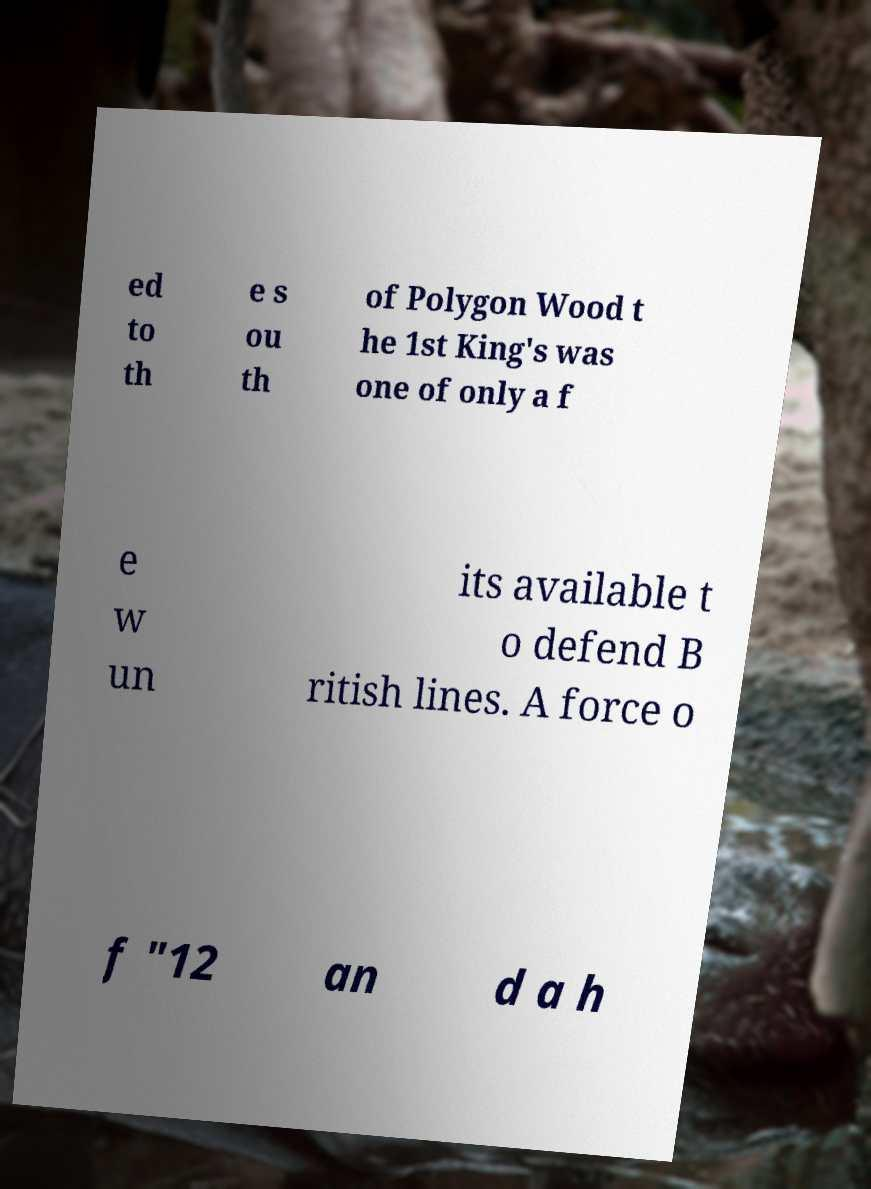Please identify and transcribe the text found in this image. ed to th e s ou th of Polygon Wood t he 1st King's was one of only a f e w un its available t o defend B ritish lines. A force o f "12 an d a h 